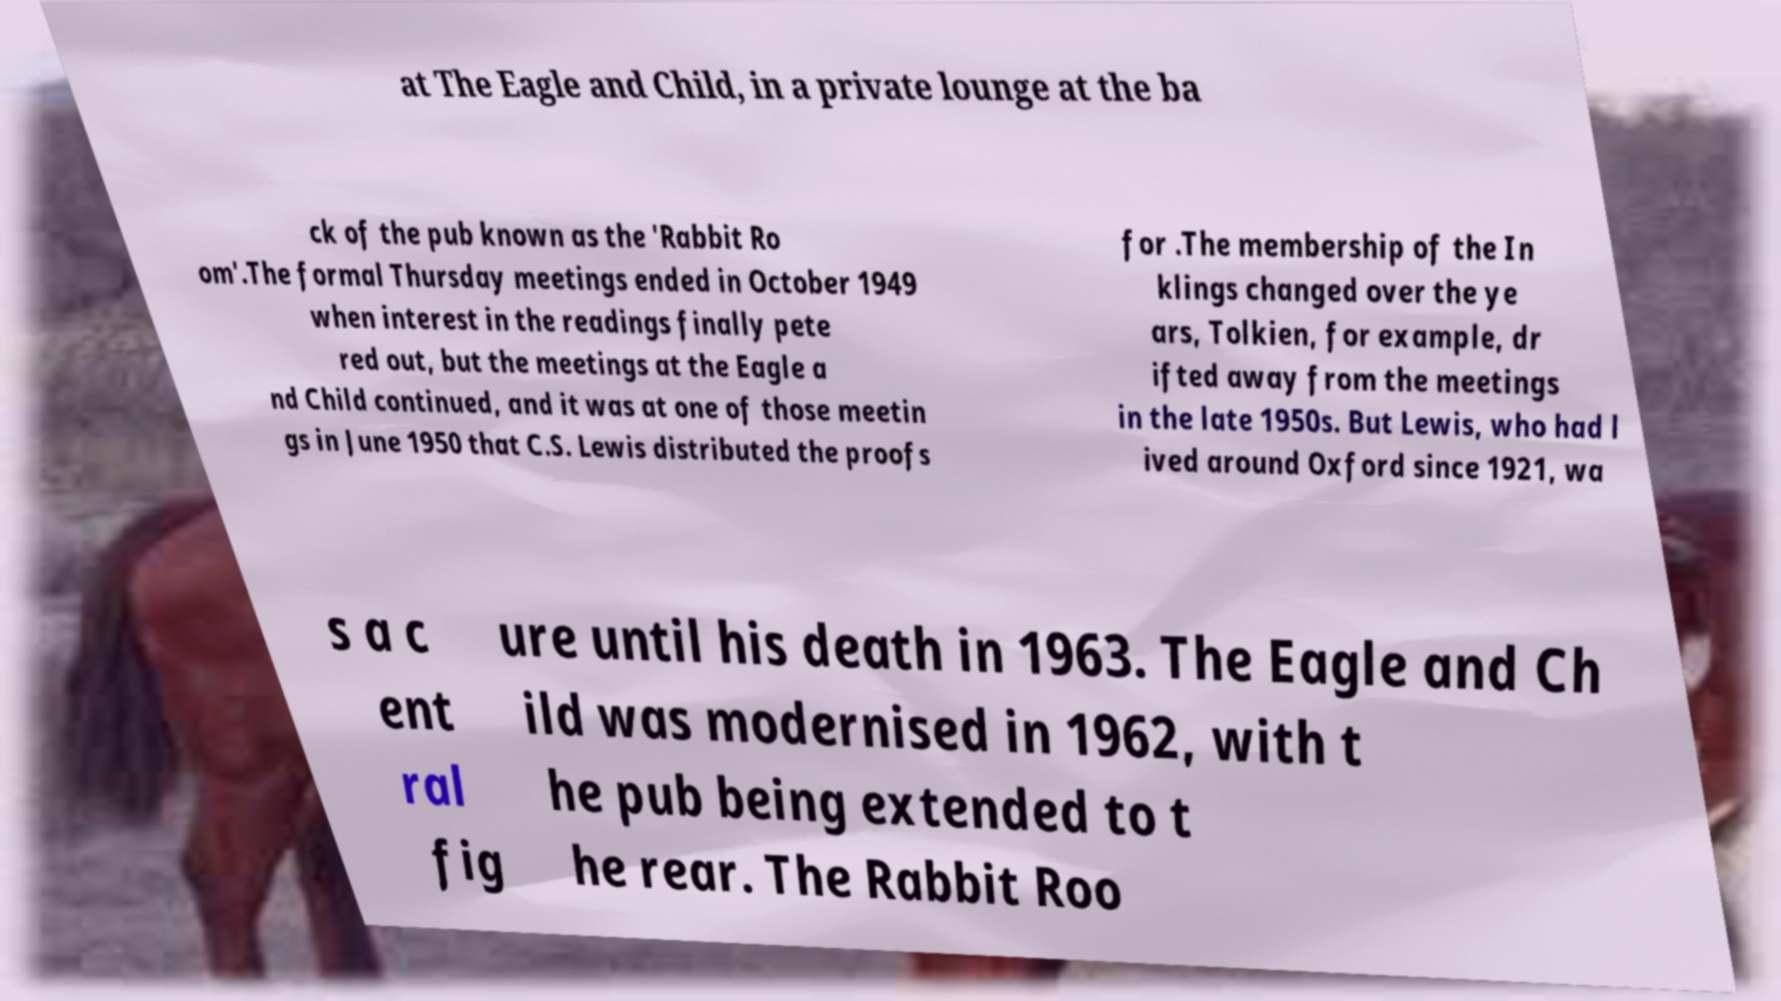Could you extract and type out the text from this image? at The Eagle and Child, in a private lounge at the ba ck of the pub known as the 'Rabbit Ro om'.The formal Thursday meetings ended in October 1949 when interest in the readings finally pete red out, but the meetings at the Eagle a nd Child continued, and it was at one of those meetin gs in June 1950 that C.S. Lewis distributed the proofs for .The membership of the In klings changed over the ye ars, Tolkien, for example, dr ifted away from the meetings in the late 1950s. But Lewis, who had l ived around Oxford since 1921, wa s a c ent ral fig ure until his death in 1963. The Eagle and Ch ild was modernised in 1962, with t he pub being extended to t he rear. The Rabbit Roo 